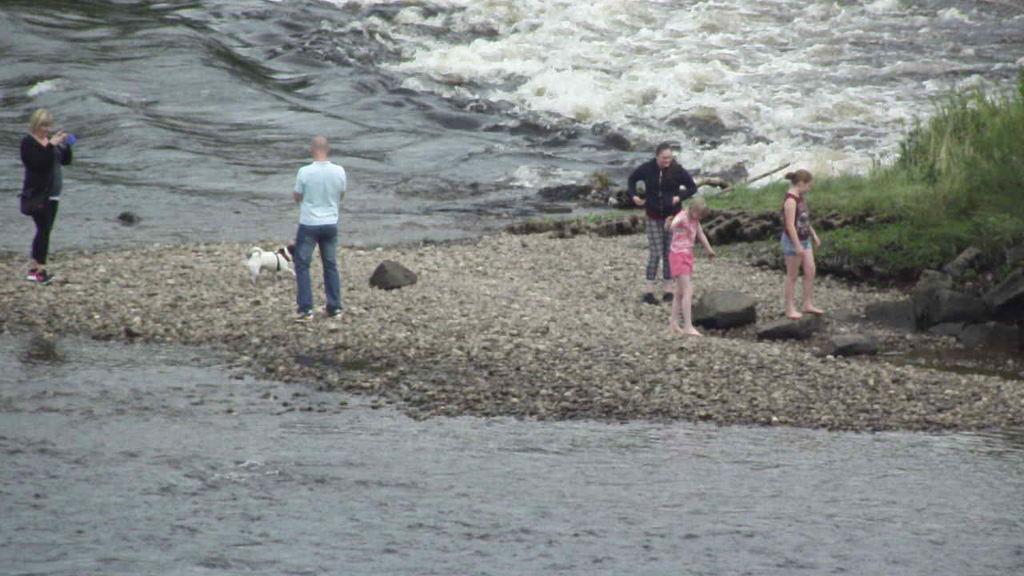Could you give a brief overview of what you see in this image? This picture shows few people Standing and we see a dog and water and grass on the ground and we see few small stones on the ground, 